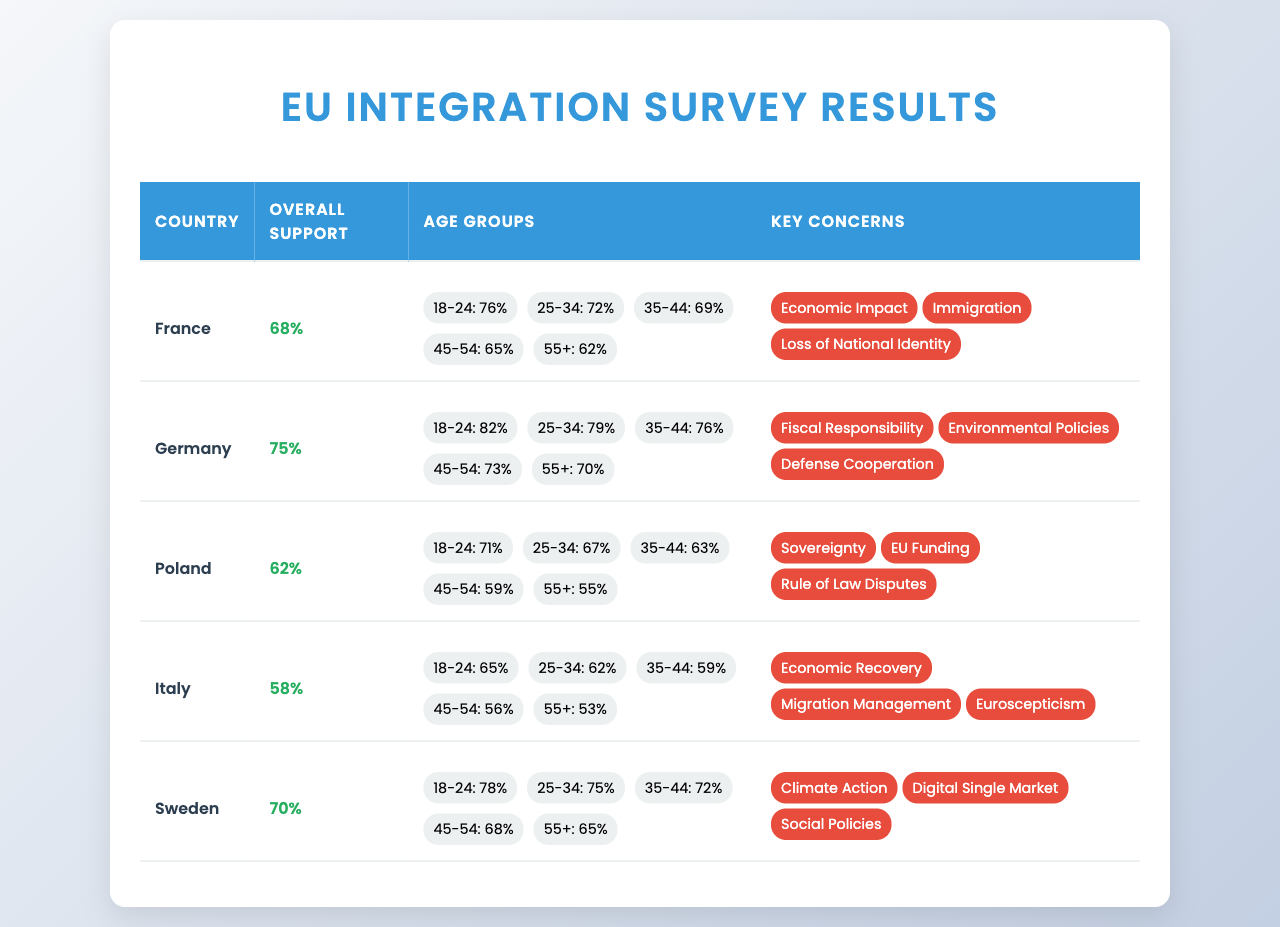What is the overall support for EU integration in Germany? The table indicates that Germany has an overall support of 75% for EU integration.
Answer: 75% Which age group in Sweden shows the highest support for EU integration? In the table, the age group 18-24 in Sweden has the highest support at 78%.
Answer: 18-24 What is the percentage of support for EU integration from the 45-54 age group in Italy? According to the table, the 45-54 age group in Italy has a support percentage of 56%.
Answer: 56% How does the overall support for EU integration in Poland compare to that in France? The overall support in Poland is 62%, while in France it's 68%. Thus, Poland's support is 6% lower than France's.
Answer: 6% lower What is the average overall support for EU integration across all five countries? The overall support percentages are: France (68%), Germany (75%), Poland (62%), Italy (58%), and Sweden (70%). The average is calculated as (68 + 75 + 62 + 58 + 70) / 5 = 66.6%.
Answer: 66.6% True or False: Italy has more overall support for EU integration than Poland. Italy's overall support is 58%, whereas Poland's is 62%. Therefore, this statement is false.
Answer: False Which country has the lowest support for EU integration, and what is that percentage? According to the table, Italy has the lowest support for EU integration at 58%.
Answer: Italy, 58% If we consider the key concerns listed for Sweden, which one is focused on environmental issues? Among Sweden's concerns, "Climate Action" is related to environmental issues as highlighted in the key concerns section.
Answer: Climate Action What is the difference in overall support between Germany and Italy? Germany's overall support is 75% while Italy's is 58%, making the difference 75 - 58 = 17%.
Answer: 17% Which country shows the least concern regarding immigration in their key concerns, and what is that concern? The data indicates that Italy's key concerns include "Migration Management," which implies a focus on immigration compared to others that mention it directly as a concern.
Answer: Italy, Migration Management 